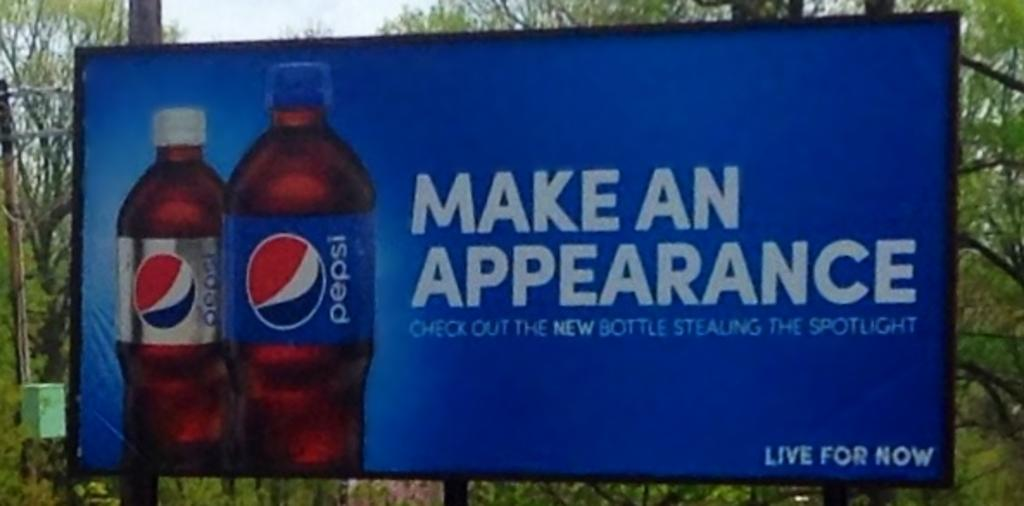<image>
Provide a brief description of the given image. A billboard is advertising a the new bottle for Pepsi and Diet Pepsi. 